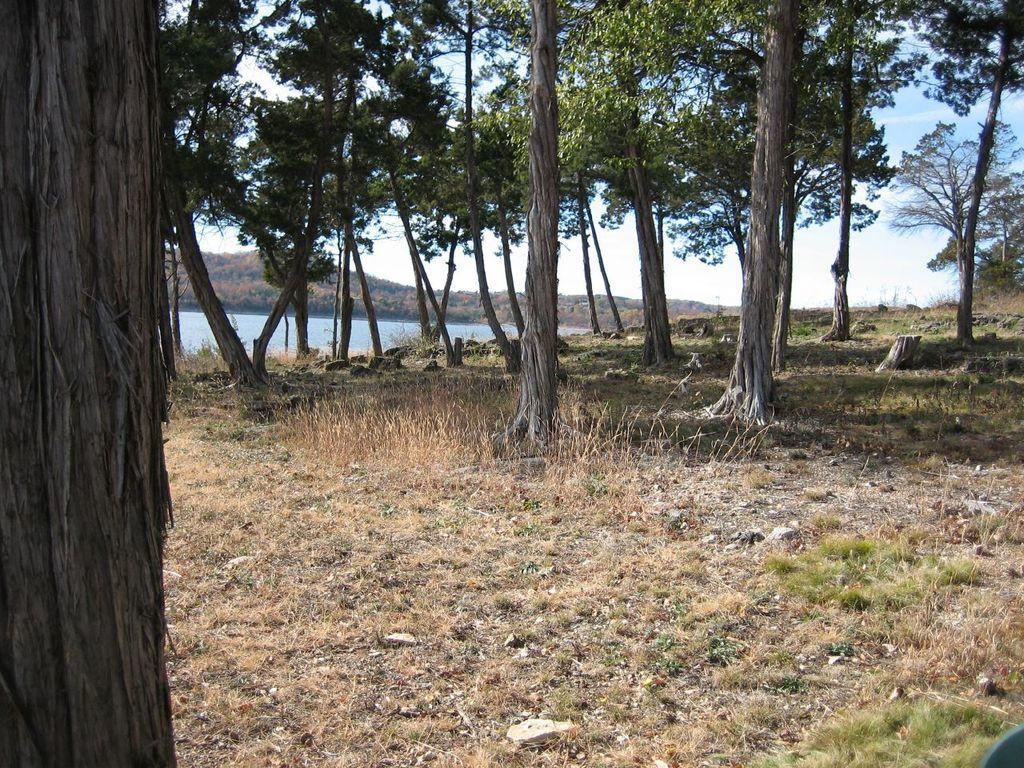Please provide a concise description of this image. There are trees, there is water and mountains at the back. 